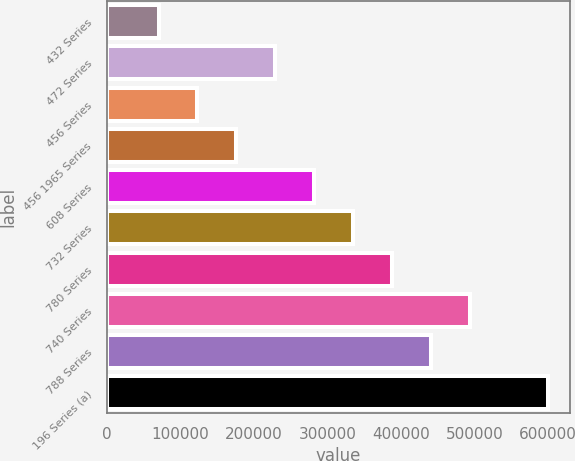<chart> <loc_0><loc_0><loc_500><loc_500><bar_chart><fcel>432 Series<fcel>472 Series<fcel>456 Series<fcel>456 1965 Series<fcel>608 Series<fcel>732 Series<fcel>780 Series<fcel>740 Series<fcel>788 Series<fcel>196 Series (a)<nl><fcel>70000<fcel>229000<fcel>123000<fcel>176000<fcel>282000<fcel>335000<fcel>388000<fcel>494000<fcel>441000<fcel>600000<nl></chart> 